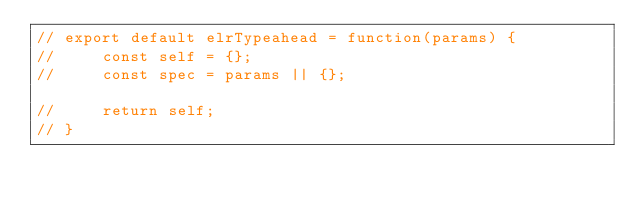<code> <loc_0><loc_0><loc_500><loc_500><_JavaScript_>// export default elrTypeahead = function(params) {
//     const self = {};
//     const spec = params || {};

//     return self;
// }</code> 